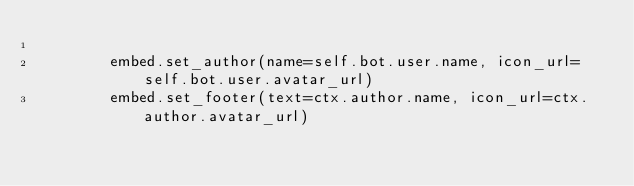<code> <loc_0><loc_0><loc_500><loc_500><_Python_>
        embed.set_author(name=self.bot.user.name, icon_url=self.bot.user.avatar_url)
        embed.set_footer(text=ctx.author.name, icon_url=ctx.author.avatar_url)
        </code> 